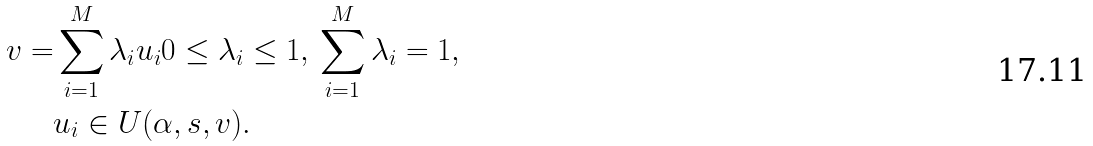<formula> <loc_0><loc_0><loc_500><loc_500>v = & \sum _ { i = 1 } ^ { M } \lambda _ { i } u _ { i } 0 \leq \lambda _ { i } \leq 1 , \, \sum _ { i = 1 } ^ { M } \lambda _ { i } = 1 , \\ & u _ { i } \in U ( \alpha , s , v ) .</formula> 